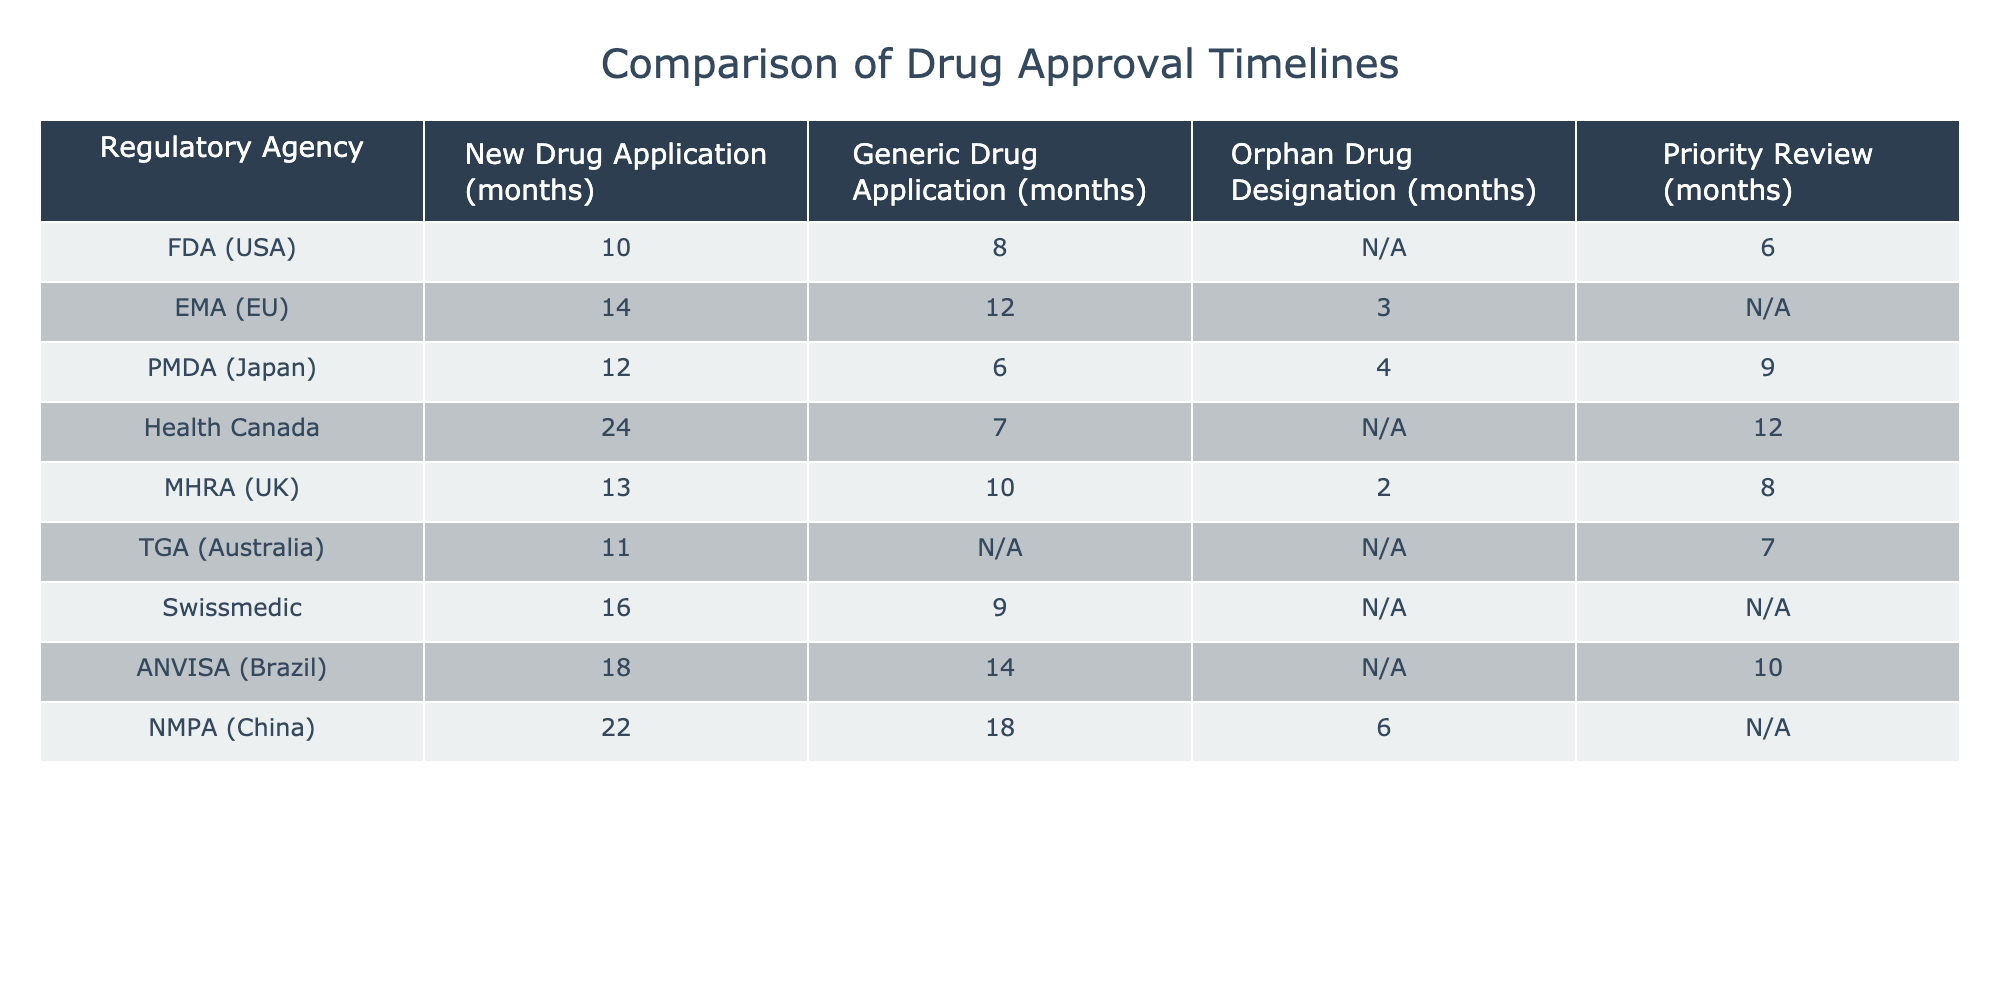What is the shortest timeline for New Drug Applications among the agencies listed? The shortest timeline for New Drug Applications is 10 months, which is observed for the FDA (USA) and TGA (Australia).
Answer: 10 months Which regulatory agency has the longest timeline for Generic Drug Applications? The longest timeline for Generic Drug Applications is 18 months, which is associated with NMPA (China).
Answer: 18 months Is there any agency that has no timeline for Orphan Drug Designation? Yes, the FDA (USA) and EMA (EU) do not have timelines listed for Orphan Drug Designation.
Answer: Yes What is the average timeline for Priority Review across all agencies listed? To find the average, we first sum the timelines that exist: 6 (FDA) + 9 (PMDA) + 12 (Health Canada) + 8 (MHRA) + 7 (TGA) = 42 months. There are 5 data points, so the average is 42/5 = 8.4 months.
Answer: 8.4 months Which agency has a shorter timeline for New Drug Applications: EMA or PMDA? EMA has a timeline of 14 months, while PMDA has 12 months for New Drug Applications. Therefore, PMDA has a shorter timeline.
Answer: PMDA How many agencies have a timeline for Orphan Drug Designation? There are three agencies with timelines for Orphan Drug Designation: EMA (3 months), PMDA (4 months), and NMPA (6 months).
Answer: 3 agencies What is the difference in timelines for Generic Drug Applications between ANVISA and Health Canada? ANVISA has a timeline of 14 months for Generic Drug Applications, while Health Canada has 7 months. The difference is 14 - 7 = 7 months.
Answer: 7 months Which regulatory agency has the highest total timeline when combining New Drug Application and Priority Review? For total timelines, the FDA has 10 (New Drug) + 6 (Priority) = 16 months; Health Canada has 24 + 12 = 36 months; PMDA has 12 + 9 = 21 months; UK has 13 + 8 = 21 months; so Health Canada has the highest at 36 months.
Answer: Health Canada How many months does the TGA take for Priority Review and how does it compare to the FDA? TGA takes 7 months for Priority Review, while FDA takes 6 months. Comparing both, TGA takes 1 month longer than the FDA.
Answer: TGA takes 1 month longer than FDA 